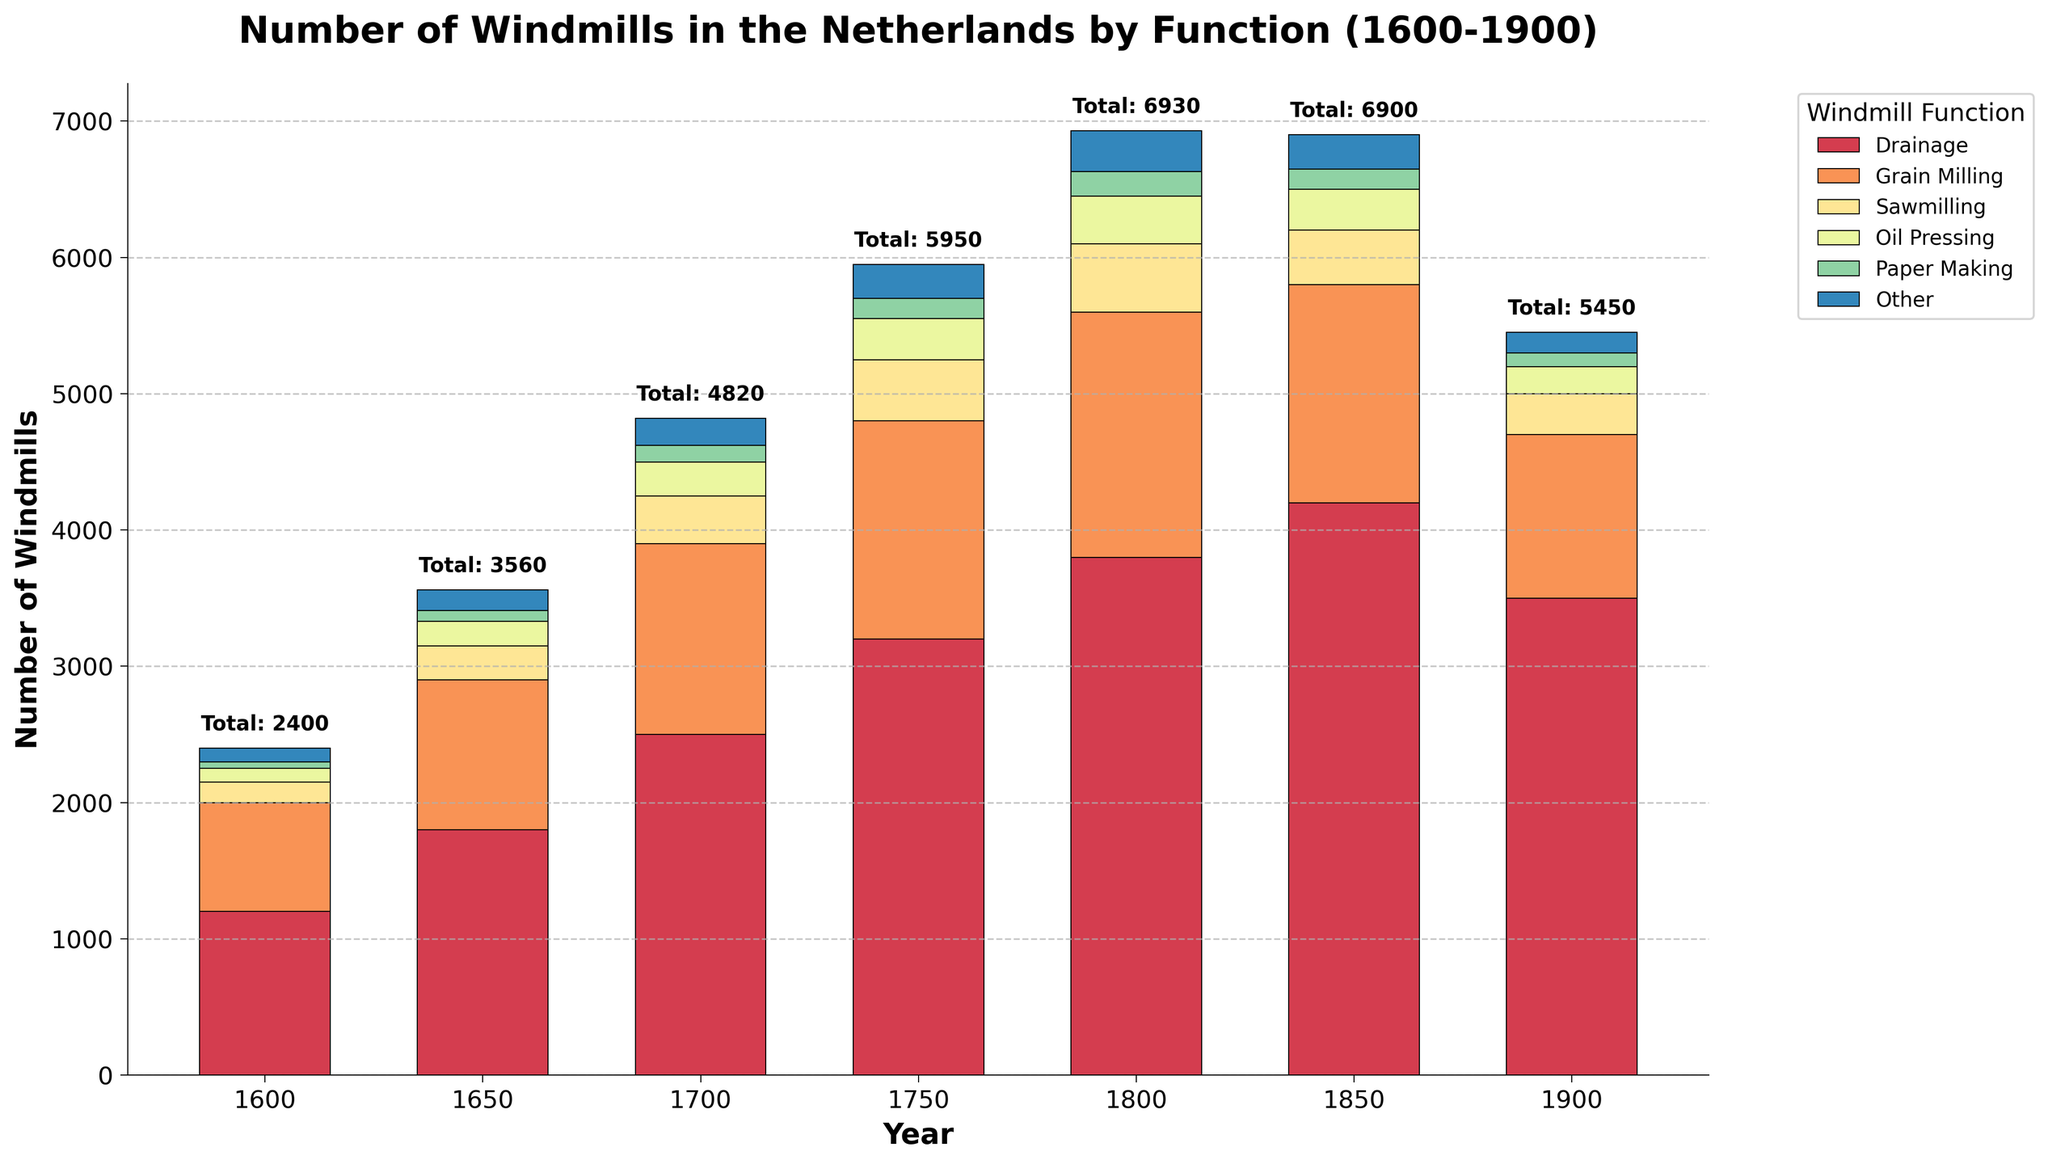Which year saw the highest total number of windmills? Examine the text annotations above the bars indicating total numbers for each year. The highest number appears next to the year 1850.
Answer: 1850 How many more drainage windmills were there in 1800 compared to 1650? Look at the height of the drainage windmill bars for both years. In 1800 there were 3800 and in 1650 there were 1800. Subtract the latter from the former: 3800 - 1800 = 2000.
Answer: 2000 In which year were there the most grain milling windmills? Compare the height of the grain milling windmills for all years. The tallest bar is found in the year 1800.
Answer: 1800 Which function had the fewest windmills in the year 1700? Look at the bars for the year 1700 and identify the shortest one. Paper Making windmills have the fewest, with 120.
Answer: Paper Making By how much did the total number of windmills increase from 1600 to 1700? Determine the total number of windmills in these years by adding up the heights of all bars. For 1600: 1200 + 800 + 150 + 100 + 50 + 100 = 2400. For 1700: 2500 + 1400 + 350 + 250 + 120 + 200 = 4820. Subtract the total for 1600 from that of 1700: 4820 - 2400 = 2420.
Answer: 2420 Between 1850 and 1900, which function experienced the greatest decrease in the number of windmills? Compare the windmill numbers for each function in 1850 and 1900. The largest decrease occurred in Drainage windmills, decreasing from 4200 to 3500.
Answer: Drainage Which year had a similar number of oil pressing and paper making windmills? Look for years where the heights of the bars for Oil Pressing and Paper Making are nearly equal. This occurs in 1750, both having around 300.
Answer: 1750 What is the combined number of sawmilling and oil pressing windmills in 1800? Add the counts for sawmilling and oil pressing windmills in 1800. Sawmilling: 500, Oil Pressing: 350. So, 500 + 350 = 850.
Answer: 850 In which year was the number of 'Other' function windmills the same as paper making windmills in 1650? Compare the height of the 'Other' function windmills across all years with the Paper Making windmills in 1650. In 1650, Paper Making windmills are at 80, and in 1900, 'Other' function windmills are also at 150, matching Paper Making in 1650.
Answer: 1900 